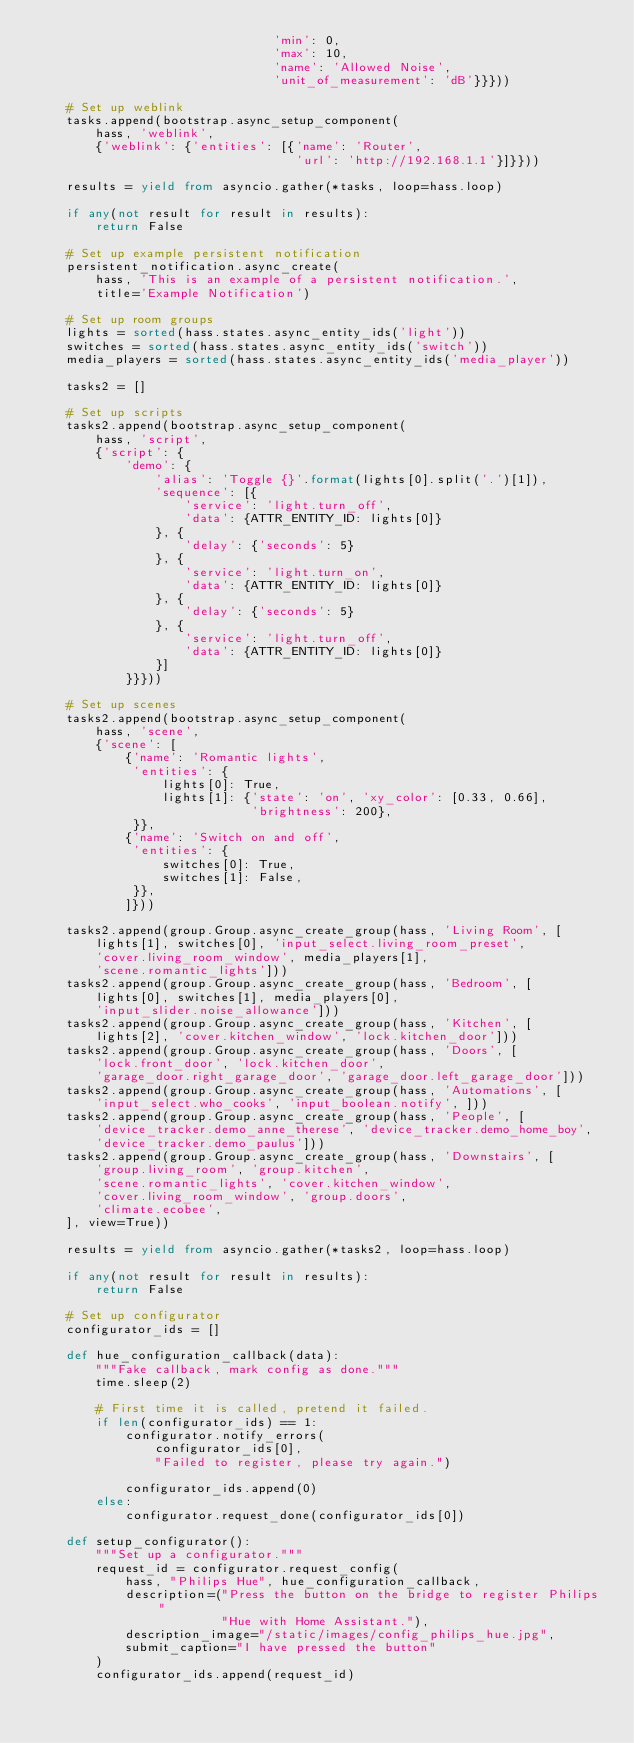<code> <loc_0><loc_0><loc_500><loc_500><_Python_>                                'min': 0,
                                'max': 10,
                                'name': 'Allowed Noise',
                                'unit_of_measurement': 'dB'}}}))

    # Set up weblink
    tasks.append(bootstrap.async_setup_component(
        hass, 'weblink',
        {'weblink': {'entities': [{'name': 'Router',
                                   'url': 'http://192.168.1.1'}]}}))

    results = yield from asyncio.gather(*tasks, loop=hass.loop)

    if any(not result for result in results):
        return False

    # Set up example persistent notification
    persistent_notification.async_create(
        hass, 'This is an example of a persistent notification.',
        title='Example Notification')

    # Set up room groups
    lights = sorted(hass.states.async_entity_ids('light'))
    switches = sorted(hass.states.async_entity_ids('switch'))
    media_players = sorted(hass.states.async_entity_ids('media_player'))

    tasks2 = []

    # Set up scripts
    tasks2.append(bootstrap.async_setup_component(
        hass, 'script',
        {'script': {
            'demo': {
                'alias': 'Toggle {}'.format(lights[0].split('.')[1]),
                'sequence': [{
                    'service': 'light.turn_off',
                    'data': {ATTR_ENTITY_ID: lights[0]}
                }, {
                    'delay': {'seconds': 5}
                }, {
                    'service': 'light.turn_on',
                    'data': {ATTR_ENTITY_ID: lights[0]}
                }, {
                    'delay': {'seconds': 5}
                }, {
                    'service': 'light.turn_off',
                    'data': {ATTR_ENTITY_ID: lights[0]}
                }]
            }}}))

    # Set up scenes
    tasks2.append(bootstrap.async_setup_component(
        hass, 'scene',
        {'scene': [
            {'name': 'Romantic lights',
             'entities': {
                 lights[0]: True,
                 lights[1]: {'state': 'on', 'xy_color': [0.33, 0.66],
                             'brightness': 200},
             }},
            {'name': 'Switch on and off',
             'entities': {
                 switches[0]: True,
                 switches[1]: False,
             }},
            ]}))

    tasks2.append(group.Group.async_create_group(hass, 'Living Room', [
        lights[1], switches[0], 'input_select.living_room_preset',
        'cover.living_room_window', media_players[1],
        'scene.romantic_lights']))
    tasks2.append(group.Group.async_create_group(hass, 'Bedroom', [
        lights[0], switches[1], media_players[0],
        'input_slider.noise_allowance']))
    tasks2.append(group.Group.async_create_group(hass, 'Kitchen', [
        lights[2], 'cover.kitchen_window', 'lock.kitchen_door']))
    tasks2.append(group.Group.async_create_group(hass, 'Doors', [
        'lock.front_door', 'lock.kitchen_door',
        'garage_door.right_garage_door', 'garage_door.left_garage_door']))
    tasks2.append(group.Group.async_create_group(hass, 'Automations', [
        'input_select.who_cooks', 'input_boolean.notify', ]))
    tasks2.append(group.Group.async_create_group(hass, 'People', [
        'device_tracker.demo_anne_therese', 'device_tracker.demo_home_boy',
        'device_tracker.demo_paulus']))
    tasks2.append(group.Group.async_create_group(hass, 'Downstairs', [
        'group.living_room', 'group.kitchen',
        'scene.romantic_lights', 'cover.kitchen_window',
        'cover.living_room_window', 'group.doors',
        'climate.ecobee',
    ], view=True))

    results = yield from asyncio.gather(*tasks2, loop=hass.loop)

    if any(not result for result in results):
        return False

    # Set up configurator
    configurator_ids = []

    def hue_configuration_callback(data):
        """Fake callback, mark config as done."""
        time.sleep(2)

        # First time it is called, pretend it failed.
        if len(configurator_ids) == 1:
            configurator.notify_errors(
                configurator_ids[0],
                "Failed to register, please try again.")

            configurator_ids.append(0)
        else:
            configurator.request_done(configurator_ids[0])

    def setup_configurator():
        """Set up a configurator."""
        request_id = configurator.request_config(
            hass, "Philips Hue", hue_configuration_callback,
            description=("Press the button on the bridge to register Philips "
                         "Hue with Home Assistant."),
            description_image="/static/images/config_philips_hue.jpg",
            submit_caption="I have pressed the button"
        )
        configurator_ids.append(request_id)
</code> 